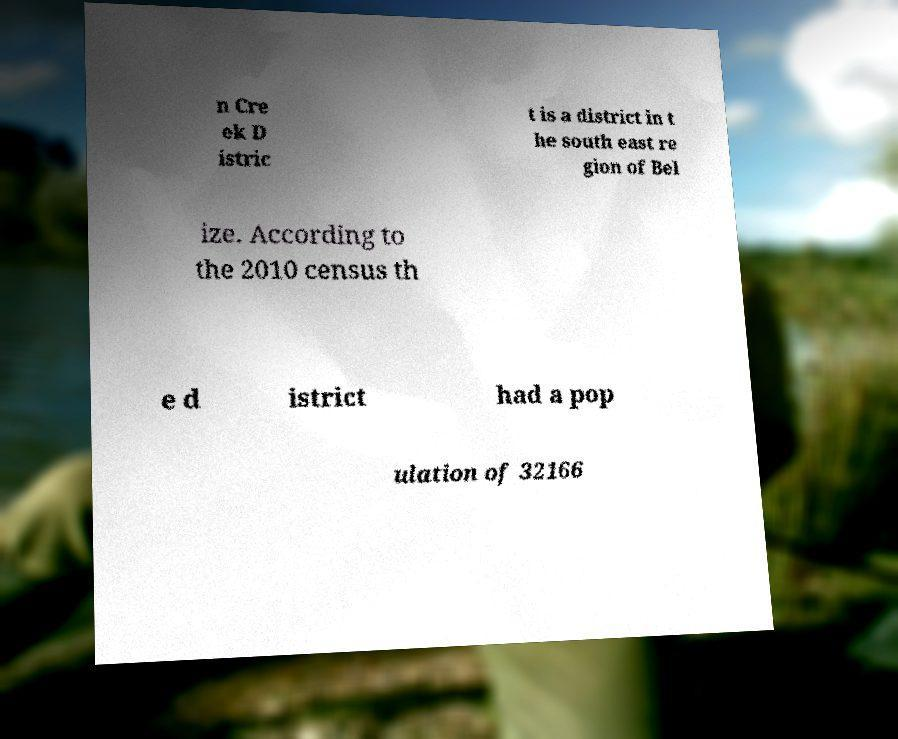Please read and relay the text visible in this image. What does it say? n Cre ek D istric t is a district in t he south east re gion of Bel ize. According to the 2010 census th e d istrict had a pop ulation of 32166 